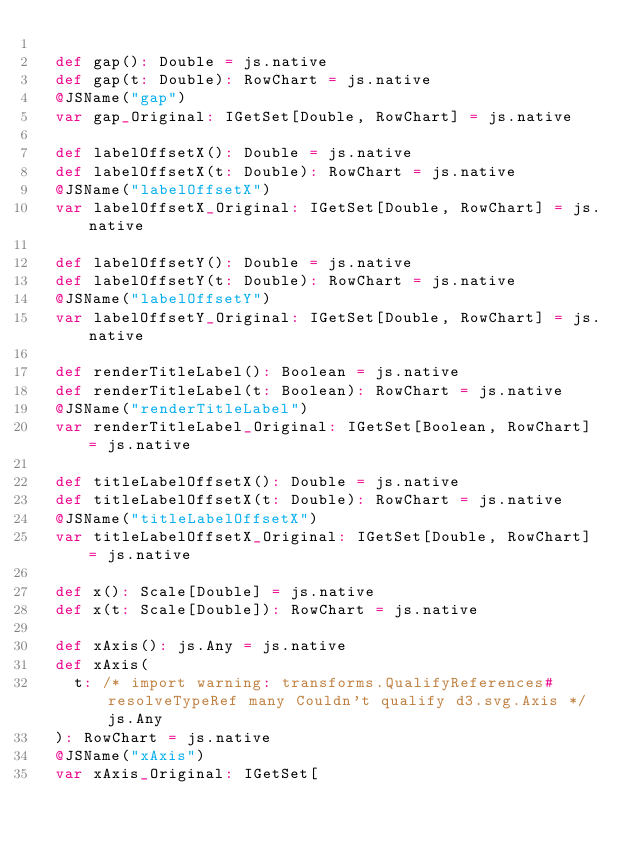Convert code to text. <code><loc_0><loc_0><loc_500><loc_500><_Scala_>  
  def gap(): Double = js.native
  def gap(t: Double): RowChart = js.native
  @JSName("gap")
  var gap_Original: IGetSet[Double, RowChart] = js.native
  
  def labelOffsetX(): Double = js.native
  def labelOffsetX(t: Double): RowChart = js.native
  @JSName("labelOffsetX")
  var labelOffsetX_Original: IGetSet[Double, RowChart] = js.native
  
  def labelOffsetY(): Double = js.native
  def labelOffsetY(t: Double): RowChart = js.native
  @JSName("labelOffsetY")
  var labelOffsetY_Original: IGetSet[Double, RowChart] = js.native
  
  def renderTitleLabel(): Boolean = js.native
  def renderTitleLabel(t: Boolean): RowChart = js.native
  @JSName("renderTitleLabel")
  var renderTitleLabel_Original: IGetSet[Boolean, RowChart] = js.native
  
  def titleLabelOffsetX(): Double = js.native
  def titleLabelOffsetX(t: Double): RowChart = js.native
  @JSName("titleLabelOffsetX")
  var titleLabelOffsetX_Original: IGetSet[Double, RowChart] = js.native
  
  def x(): Scale[Double] = js.native
  def x(t: Scale[Double]): RowChart = js.native
  
  def xAxis(): js.Any = js.native
  def xAxis(
    t: /* import warning: transforms.QualifyReferences#resolveTypeRef many Couldn't qualify d3.svg.Axis */ js.Any
  ): RowChart = js.native
  @JSName("xAxis")
  var xAxis_Original: IGetSet[</code> 